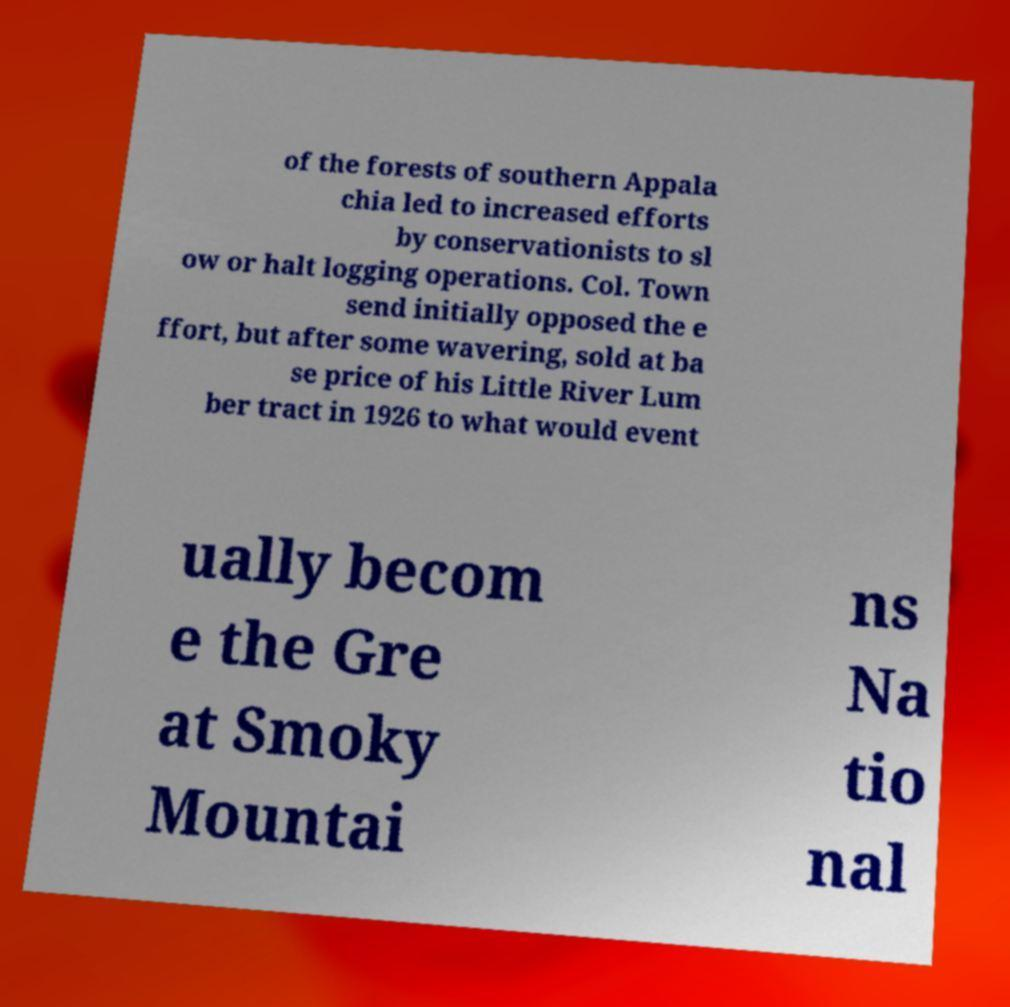Could you extract and type out the text from this image? of the forests of southern Appala chia led to increased efforts by conservationists to sl ow or halt logging operations. Col. Town send initially opposed the e ffort, but after some wavering, sold at ba se price of his Little River Lum ber tract in 1926 to what would event ually becom e the Gre at Smoky Mountai ns Na tio nal 